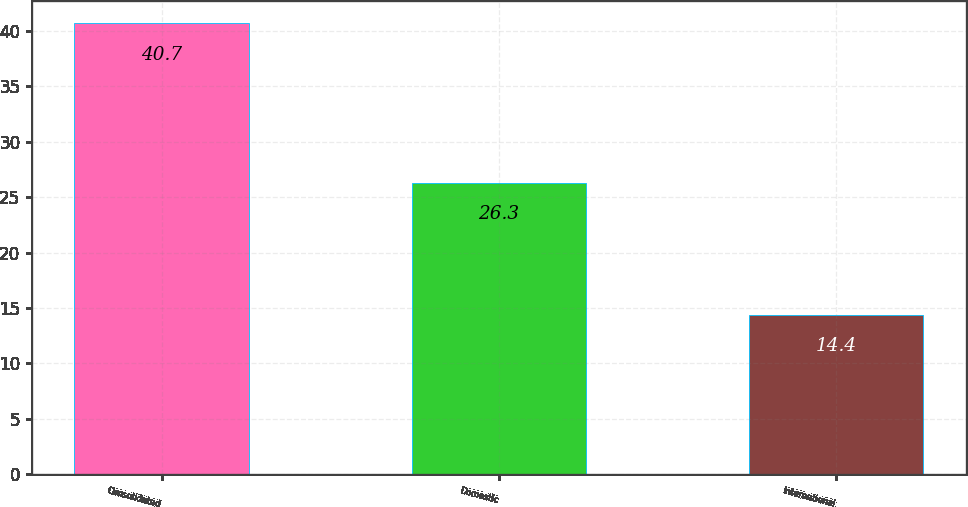Convert chart to OTSL. <chart><loc_0><loc_0><loc_500><loc_500><bar_chart><fcel>Consolidated<fcel>Domestic<fcel>International<nl><fcel>40.7<fcel>26.3<fcel>14.4<nl></chart> 